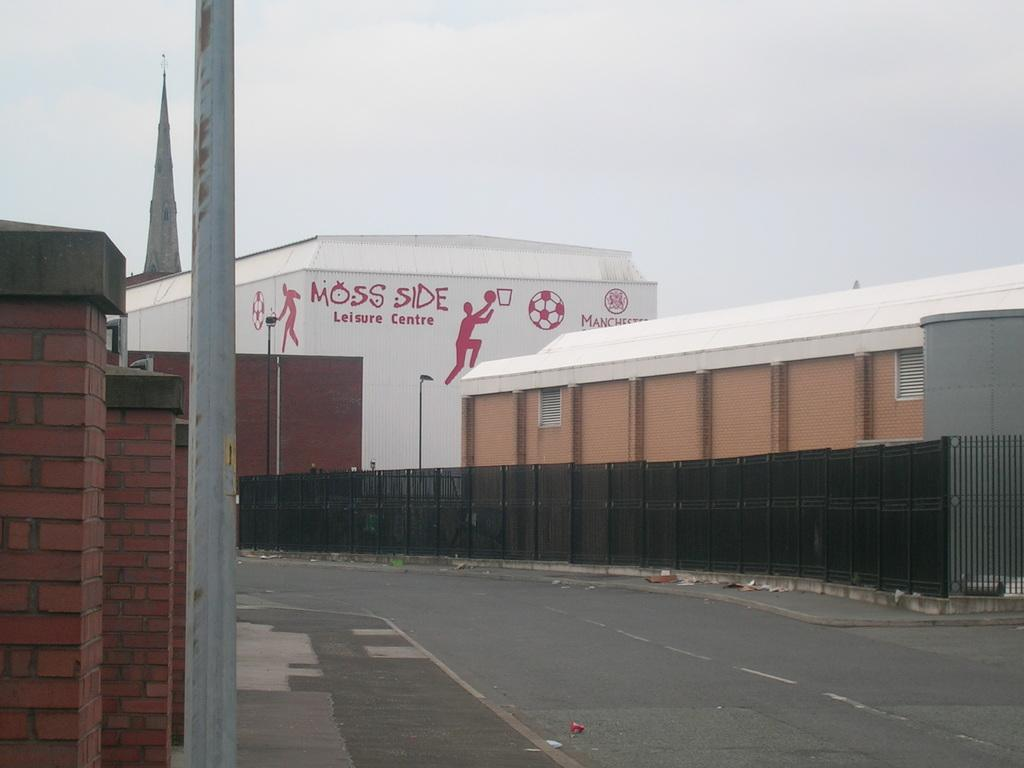What is the main feature of the image? There is a road in the image. What can be seen alongside the road? There are buildings beside the road. Can you describe the surroundings of the road? The surroundings of the road include buildings. Are there any bears walking on the road in the image? No, there are no bears present in the image. 